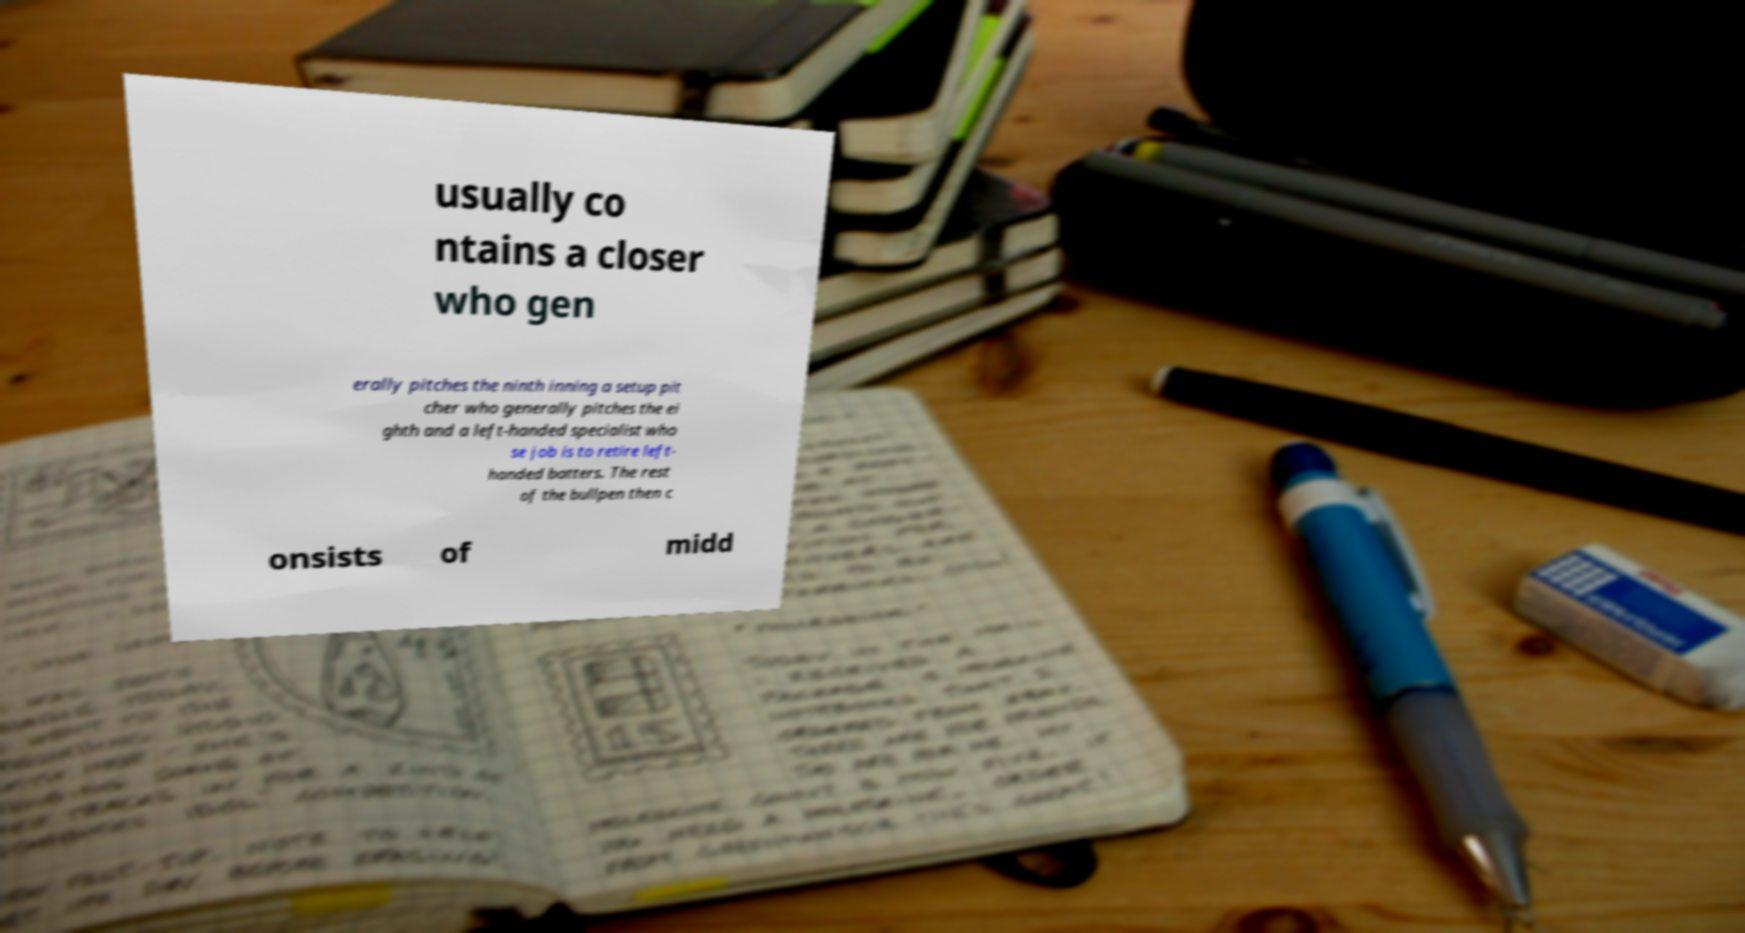There's text embedded in this image that I need extracted. Can you transcribe it verbatim? usually co ntains a closer who gen erally pitches the ninth inning a setup pit cher who generally pitches the ei ghth and a left-handed specialist who se job is to retire left- handed batters. The rest of the bullpen then c onsists of midd 